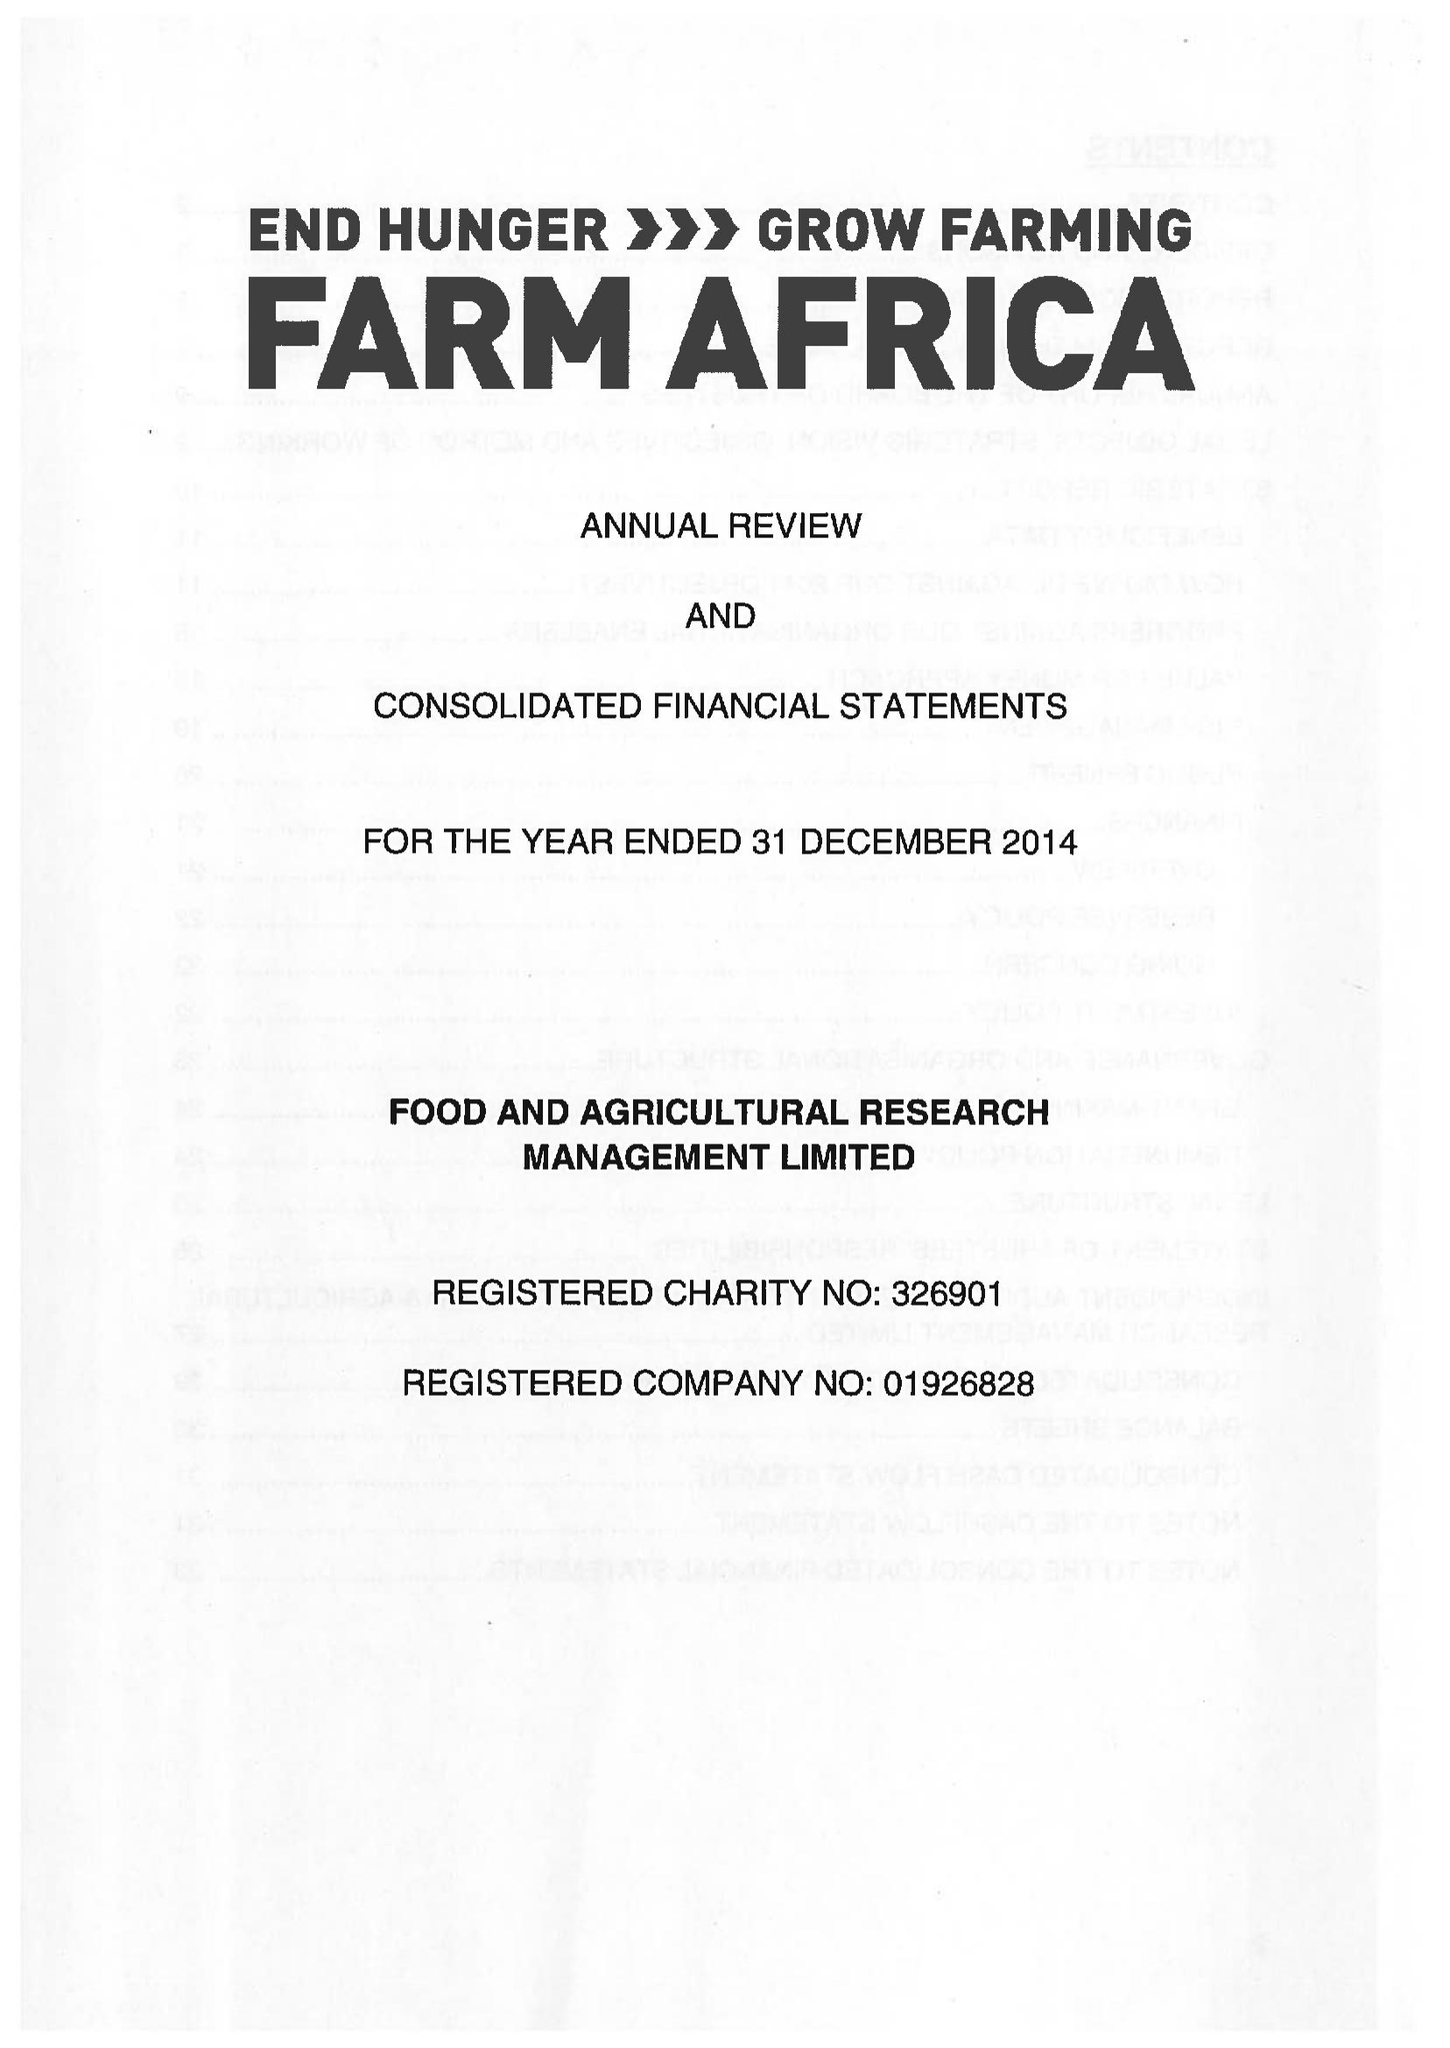What is the value for the charity_name?
Answer the question using a single word or phrase. Farm Africa Ltd. 